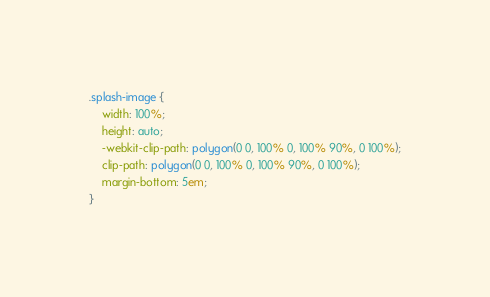<code> <loc_0><loc_0><loc_500><loc_500><_CSS_>.splash-image {
    width: 100%;
    height: auto;
    -webkit-clip-path: polygon(0 0, 100% 0, 100% 90%, 0 100%);
    clip-path: polygon(0 0, 100% 0, 100% 90%, 0 100%);
    margin-bottom: 5em;
}
</code> 